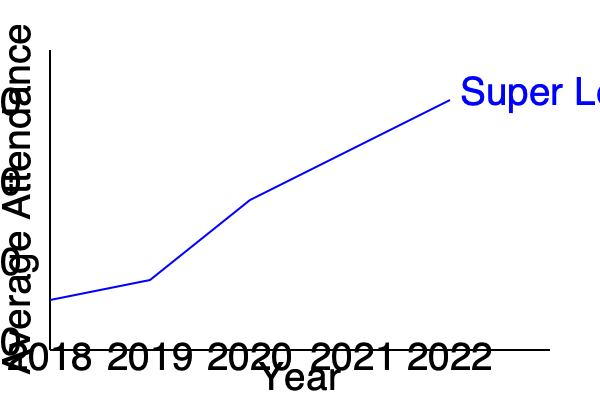Based on the line graph showing average attendance figures for Super League matches from 2018 to 2022, what was the approximate increase in average attendance between 2020 and 2022? To find the increase in average attendance between 2020 and 2022, we need to:

1. Identify the average attendance for 2020:
   - This corresponds to the point on the graph for 2020 (x-axis)
   - The y-value is approximately 10,000

2. Identify the average attendance for 2022:
   - This corresponds to the point on the graph for 2022 (x-axis)
   - The y-value is approximately 15,000

3. Calculate the difference:
   $15,000 - 10,000 = 5,000$

Therefore, the approximate increase in average attendance between 2020 and 2022 was 5,000.
Answer: 5,000 